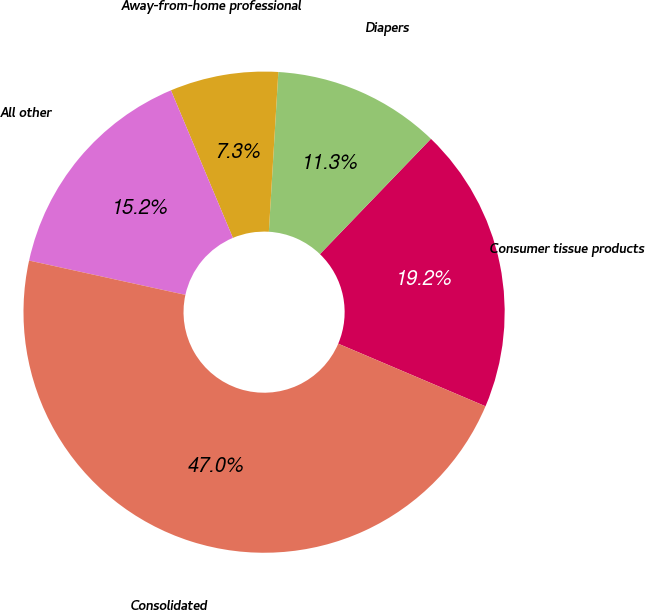Convert chart. <chart><loc_0><loc_0><loc_500><loc_500><pie_chart><fcel>Consumer tissue products<fcel>Diapers<fcel>Away-from-home professional<fcel>All other<fcel>Consolidated<nl><fcel>19.2%<fcel>11.25%<fcel>7.27%<fcel>15.23%<fcel>47.04%<nl></chart> 